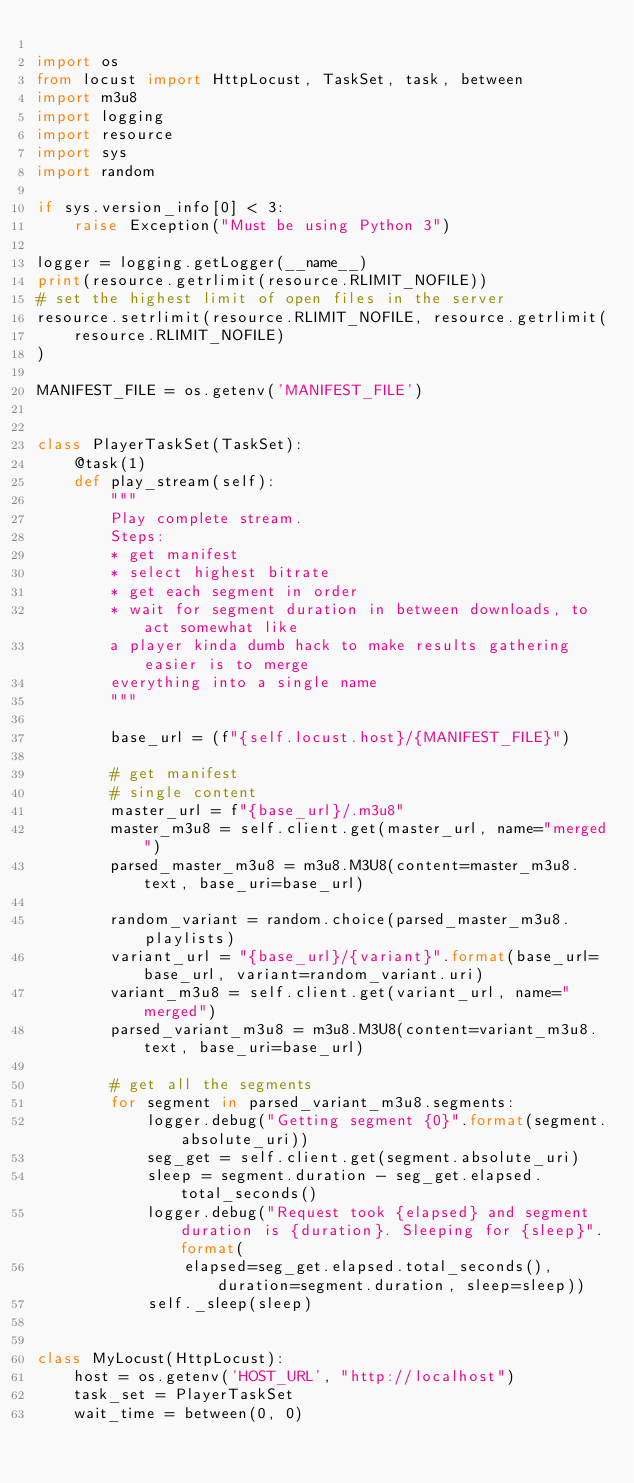Convert code to text. <code><loc_0><loc_0><loc_500><loc_500><_Python_>
import os
from locust import HttpLocust, TaskSet, task, between
import m3u8
import logging
import resource
import sys
import random

if sys.version_info[0] < 3:
    raise Exception("Must be using Python 3")

logger = logging.getLogger(__name__)
print(resource.getrlimit(resource.RLIMIT_NOFILE))
# set the highest limit of open files in the server
resource.setrlimit(resource.RLIMIT_NOFILE, resource.getrlimit(
    resource.RLIMIT_NOFILE)
)

MANIFEST_FILE = os.getenv('MANIFEST_FILE')


class PlayerTaskSet(TaskSet):
    @task(1)
    def play_stream(self):
        """
        Play complete stream.
        Steps:
        * get manifest
        * select highest bitrate
        * get each segment in order
        * wait for segment duration in between downloads, to act somewhat like
        a player kinda dumb hack to make results gathering easier is to merge
        everything into a single name
        """

        base_url = (f"{self.locust.host}/{MANIFEST_FILE}")

        # get manifest
        # single content
        master_url = f"{base_url}/.m3u8"
        master_m3u8 = self.client.get(master_url, name="merged")
        parsed_master_m3u8 = m3u8.M3U8(content=master_m3u8.text, base_uri=base_url)

        random_variant = random.choice(parsed_master_m3u8.playlists)
        variant_url = "{base_url}/{variant}".format(base_url=base_url, variant=random_variant.uri)
        variant_m3u8 = self.client.get(variant_url, name="merged")
        parsed_variant_m3u8 = m3u8.M3U8(content=variant_m3u8.text, base_uri=base_url)

        # get all the segments
        for segment in parsed_variant_m3u8.segments:
            logger.debug("Getting segment {0}".format(segment.absolute_uri))
            seg_get = self.client.get(segment.absolute_uri)
            sleep = segment.duration - seg_get.elapsed.total_seconds()
            logger.debug("Request took {elapsed} and segment duration is {duration}. Sleeping for {sleep}".format(
                elapsed=seg_get.elapsed.total_seconds(), duration=segment.duration, sleep=sleep))
            self._sleep(sleep)


class MyLocust(HttpLocust):
    host = os.getenv('HOST_URL', "http://localhost")
    task_set = PlayerTaskSet
    wait_time = between(0, 0)
</code> 